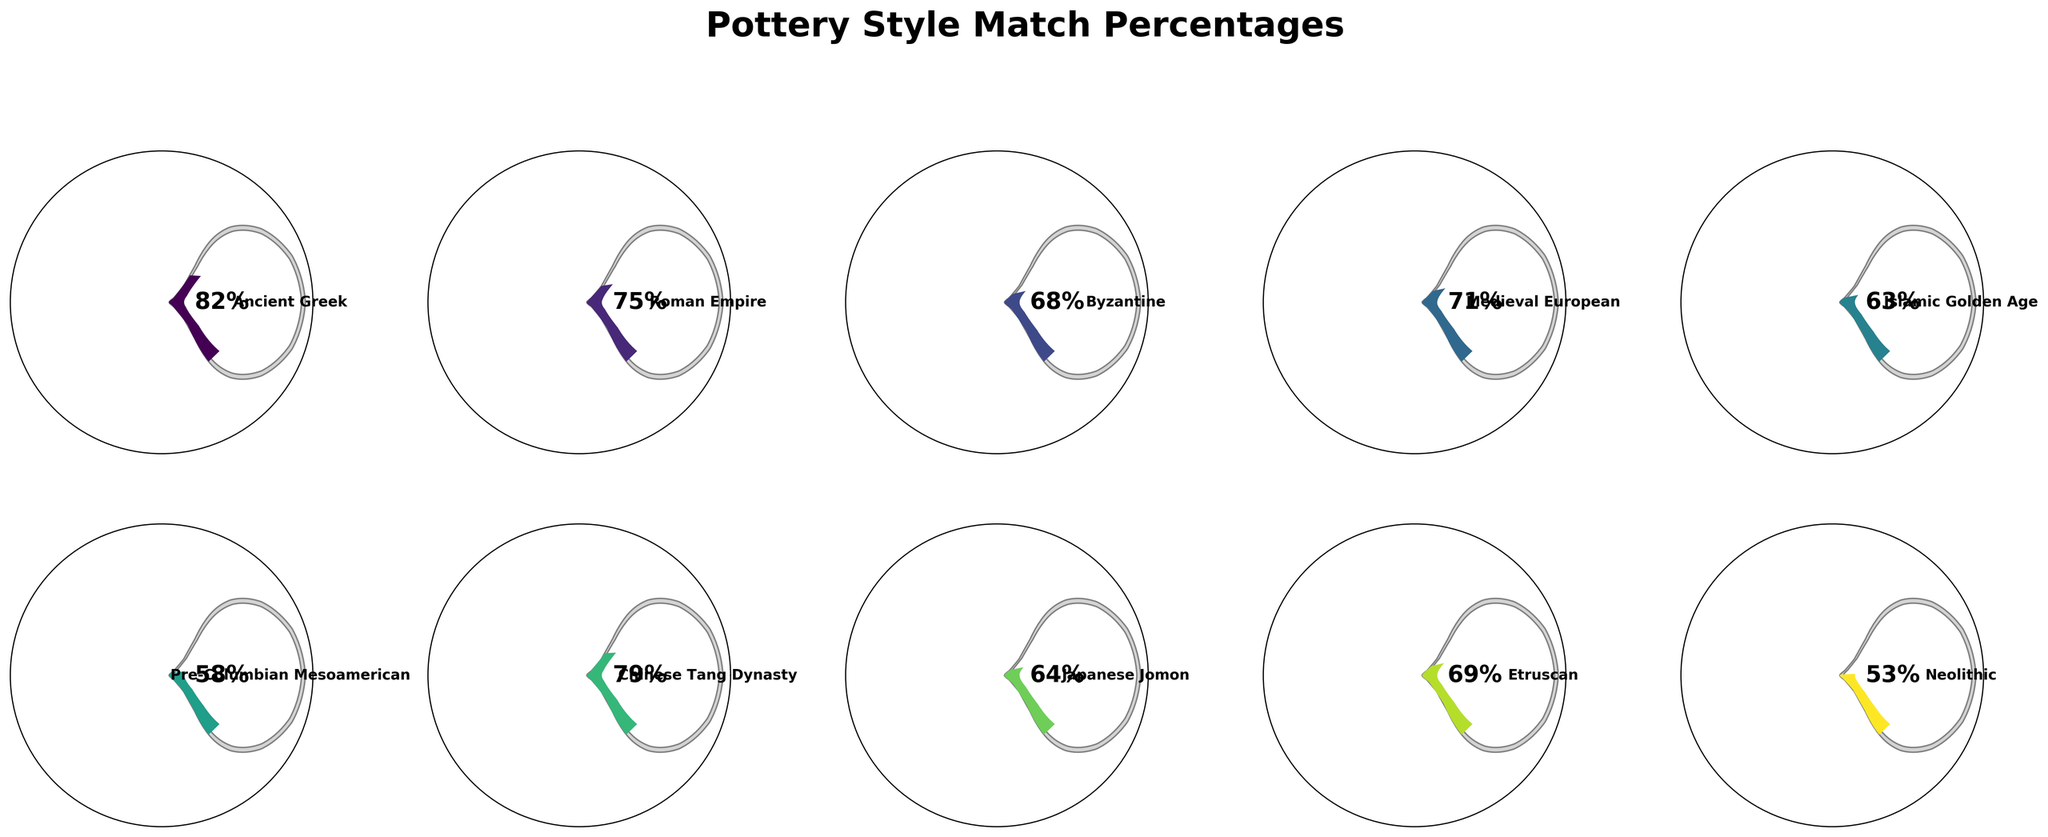What's the title of the figure? The title is usually located at the top of the figure, indicating the main topic or purpose of the visualization. In this case, it is "Pottery Style Match Percentages" as indicated by the provided context.
Answer: Pottery Style Match Percentages What is the highest match percentage shown in the figure and which pottery style does it correspond to? To find the highest match percentage, look for the gauge that reaches the furthest towards the right side of the semicircle. The corresponding text label at the top of that gauge indicates the pottery style. The highest match percentage is 82%, corresponding to Ancient Greek style.
Answer: 82%, Ancient Greek Which pottery style has the lowest match percentage? To determine the lowest match percentage, identify the gauge with the shortest fill on the left side of the semicircle. The corresponding text label at the top of that gauge indicates the pottery style. The lowest match percentage in the figure is 53%, corresponding to Neolithic style.
Answer: Neolithic How many pottery styles have a match percentage equal to or greater than 70%? Count the number of gauges where the filled portion reaches or exceeds the 70% mark, indicated on the semicircle scale. There are four such gauges: Ancient Greek (82%), Roman Empire (75%), Chinese Tang Dynasty (79%), and Medieval European (71%).
Answer: 4 What's the average match percentage for pottery styles from Roman Empire, Byzantine, and Medieval European? Average calculation involves summing up the match percentages for these three styles and dividing by the number of styles. Sum is 75 + 68 + 71 = 214. Divide this by 3 to get the average: 214 / 3 = approximately 71.33%.
Answer: Approximately 71.33% Which pottery styles have match percentages between 60% and 70%? Look for the gauges that have their fill between 60% and 70%. The corresponding text labels at the top indicate the styles. These are Byzantine (68%), Japanese Jomon (64%), and Etruscan (69%).
Answer: Byzantine, Japanese Jomon, Etruscan Is the match percentage for Pre-Columbian Mesoamerican higher or lower than that for Islamic Golden Age? Compare the lengths of the fill for Pre-Columbian Mesoamerican (58%) and Islamic Golden Age (63%). The gauge for Islamic Golden Age indicates a higher match percentage.
Answer: Lower What is the difference in match percentage between Chinese Tang Dynasty and Neolithic styles? Subtract the match percentage of Neolithic (53%) from that of Chinese Tang Dynasty (79%). Calculation: 79 - 53 = 26%.
Answer: 26% What proportion of the pottery styles have match percentages over 75%? Count the number of pottery styles with match percentages over 75% (Ancient Greek and Chinese Tang Dynasty), then divide this number by the total number of styles (10). Calculation: 2/10 = 0.20 or 20%.
Answer: 20% Which two pottery styles are closest in their match percentages? Find pairs of gauges with very close lengths of fill. Byzantine (68%) and Etruscan (69%) have the closest match percentages, differing by just 1%.
Answer: Byzantine and Etruscan 